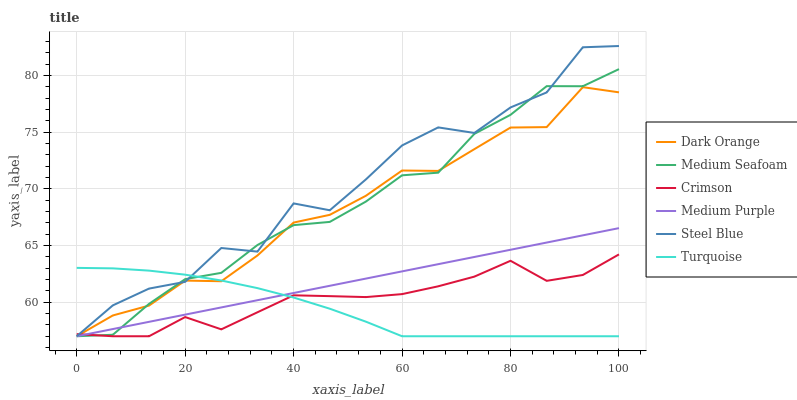Does Turquoise have the minimum area under the curve?
Answer yes or no. Yes. Does Steel Blue have the maximum area under the curve?
Answer yes or no. Yes. Does Steel Blue have the minimum area under the curve?
Answer yes or no. No. Does Turquoise have the maximum area under the curve?
Answer yes or no. No. Is Medium Purple the smoothest?
Answer yes or no. Yes. Is Steel Blue the roughest?
Answer yes or no. Yes. Is Turquoise the smoothest?
Answer yes or no. No. Is Turquoise the roughest?
Answer yes or no. No. Does Turquoise have the highest value?
Answer yes or no. No. 